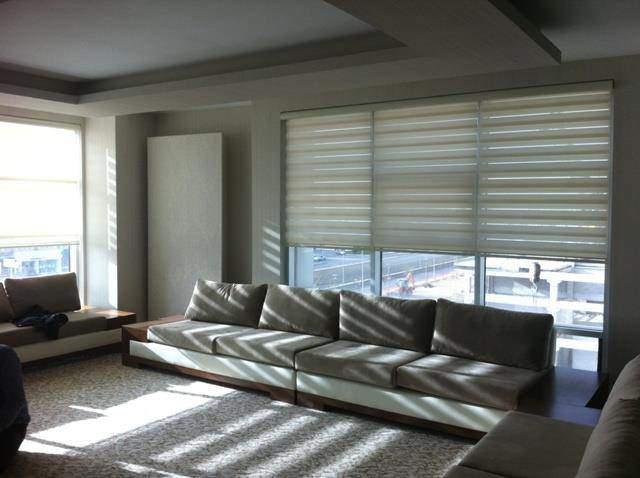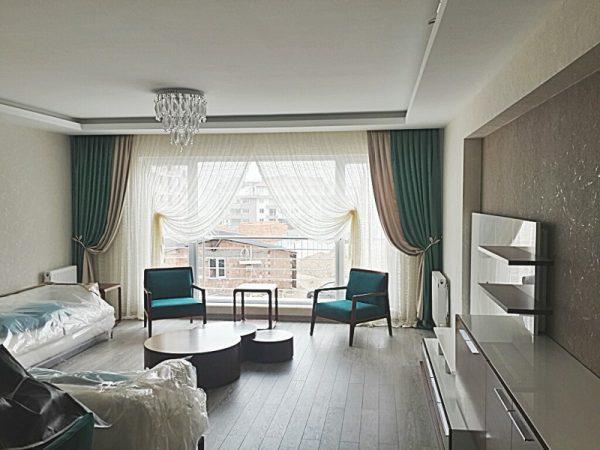The first image is the image on the left, the second image is the image on the right. Examine the images to the left and right. Is the description "In at least one image there is a grey four seat sofa in front of three white open blinds." accurate? Answer yes or no. Yes. The first image is the image on the left, the second image is the image on the right. Evaluate the accuracy of this statement regarding the images: "The couch in the right hand image is in front of a window with sunlight coming in.". Is it true? Answer yes or no. No. 